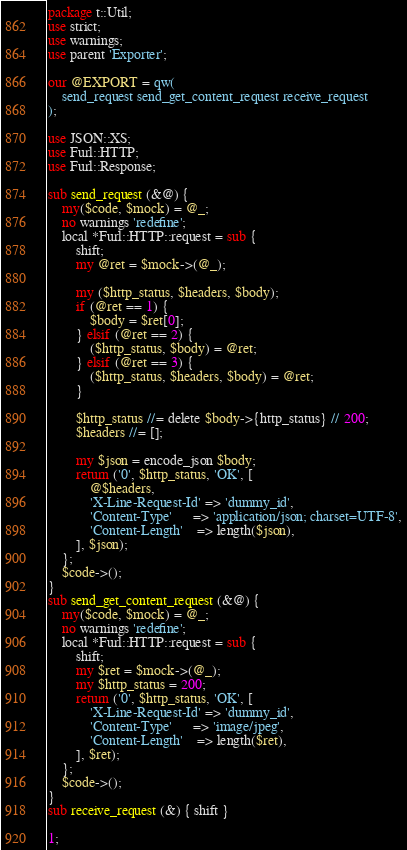<code> <loc_0><loc_0><loc_500><loc_500><_Perl_>package t::Util;
use strict;
use warnings;
use parent 'Exporter';

our @EXPORT = qw(
    send_request send_get_content_request receive_request
);

use JSON::XS;
use Furl::HTTP;
use Furl::Response;

sub send_request (&@) {
    my($code, $mock) = @_;
    no warnings 'redefine';
    local *Furl::HTTP::request = sub {
        shift;
        my @ret = $mock->(@_);

        my ($http_status, $headers, $body);
        if (@ret == 1) {
            $body = $ret[0];
        } elsif (@ret == 2) {
            ($http_status, $body) = @ret;
        } elsif (@ret == 3) {
            ($http_status, $headers, $body) = @ret;
        }

        $http_status //= delete $body->{http_status} // 200;
        $headers //= [];

        my $json = encode_json $body;
        return ('0', $http_status, 'OK', [
            @$headers,
            'X-Line-Request-Id' => 'dummy_id',
            'Content-Type'      => 'application/json; charset=UTF-8',
            'Content-Length'    => length($json),
        ], $json);
    };
    $code->();
}
sub send_get_content_request (&@) {
    my($code, $mock) = @_;
    no warnings 'redefine';
    local *Furl::HTTP::request = sub {
        shift;
        my $ret = $mock->(@_);
        my $http_status = 200;
        return ('0', $http_status, 'OK', [
            'X-Line-Request-Id' => 'dummy_id',
            'Content-Type'      => 'image/jpeg',
            'Content-Length'    => length($ret),
        ], $ret);
    };
    $code->();
}
sub receive_request (&) { shift }

1;
</code> 